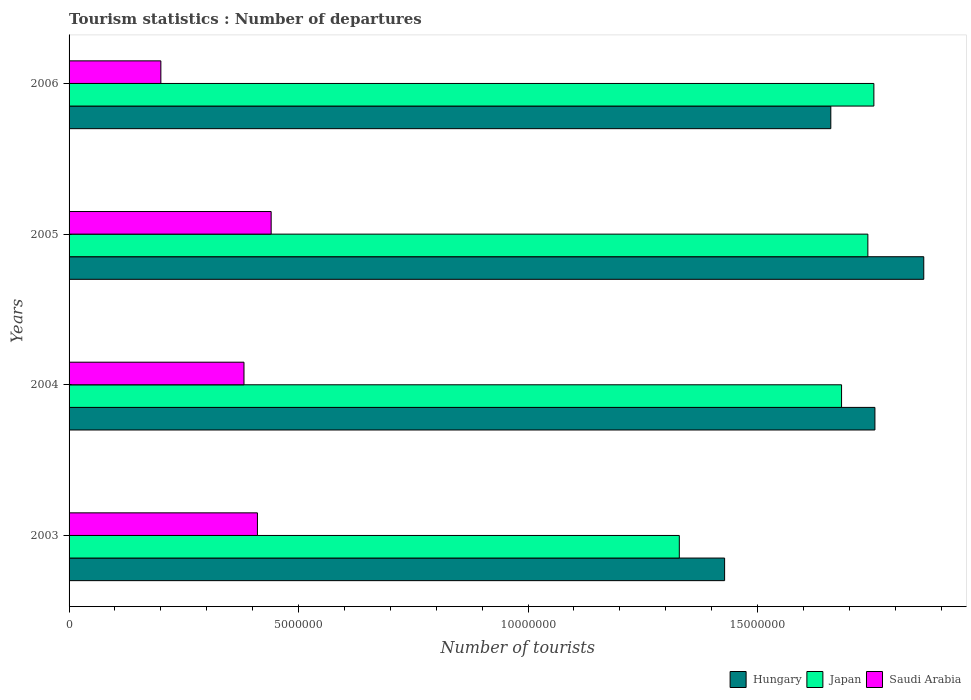How many different coloured bars are there?
Offer a very short reply. 3. How many groups of bars are there?
Give a very brief answer. 4. How many bars are there on the 3rd tick from the bottom?
Give a very brief answer. 3. What is the label of the 1st group of bars from the top?
Provide a short and direct response. 2006. What is the number of tourist departures in Japan in 2005?
Provide a short and direct response. 1.74e+07. Across all years, what is the maximum number of tourist departures in Saudi Arabia?
Ensure brevity in your answer.  4.40e+06. Across all years, what is the minimum number of tourist departures in Japan?
Your response must be concise. 1.33e+07. In which year was the number of tourist departures in Japan maximum?
Give a very brief answer. 2006. In which year was the number of tourist departures in Japan minimum?
Provide a short and direct response. 2003. What is the total number of tourist departures in Saudi Arabia in the graph?
Your answer should be compact. 1.43e+07. What is the difference between the number of tourist departures in Japan in 2005 and that in 2006?
Ensure brevity in your answer.  -1.31e+05. What is the difference between the number of tourist departures in Hungary in 2004 and the number of tourist departures in Saudi Arabia in 2005?
Provide a short and direct response. 1.32e+07. What is the average number of tourist departures in Hungary per year?
Your response must be concise. 1.68e+07. In the year 2003, what is the difference between the number of tourist departures in Hungary and number of tourist departures in Japan?
Keep it short and to the point. 9.87e+05. In how many years, is the number of tourist departures in Saudi Arabia greater than 6000000 ?
Your answer should be very brief. 0. What is the ratio of the number of tourist departures in Hungary in 2004 to that in 2006?
Provide a succinct answer. 1.06. What is the difference between the highest and the second highest number of tourist departures in Saudi Arabia?
Your response must be concise. 2.99e+05. What is the difference between the highest and the lowest number of tourist departures in Japan?
Your answer should be very brief. 4.24e+06. In how many years, is the number of tourist departures in Hungary greater than the average number of tourist departures in Hungary taken over all years?
Provide a short and direct response. 2. What does the 1st bar from the top in 2006 represents?
Keep it short and to the point. Saudi Arabia. What does the 1st bar from the bottom in 2003 represents?
Your answer should be very brief. Hungary. What is the difference between two consecutive major ticks on the X-axis?
Your answer should be very brief. 5.00e+06. Are the values on the major ticks of X-axis written in scientific E-notation?
Your answer should be very brief. No. Does the graph contain any zero values?
Ensure brevity in your answer.  No. Does the graph contain grids?
Make the answer very short. No. How many legend labels are there?
Make the answer very short. 3. What is the title of the graph?
Your response must be concise. Tourism statistics : Number of departures. What is the label or title of the X-axis?
Your answer should be very brief. Number of tourists. What is the label or title of the Y-axis?
Your answer should be compact. Years. What is the Number of tourists in Hungary in 2003?
Ensure brevity in your answer.  1.43e+07. What is the Number of tourists in Japan in 2003?
Ensure brevity in your answer.  1.33e+07. What is the Number of tourists of Saudi Arabia in 2003?
Give a very brief answer. 4.10e+06. What is the Number of tourists in Hungary in 2004?
Make the answer very short. 1.76e+07. What is the Number of tourists of Japan in 2004?
Your answer should be very brief. 1.68e+07. What is the Number of tourists of Saudi Arabia in 2004?
Your answer should be compact. 3.81e+06. What is the Number of tourists of Hungary in 2005?
Provide a succinct answer. 1.86e+07. What is the Number of tourists in Japan in 2005?
Offer a terse response. 1.74e+07. What is the Number of tourists in Saudi Arabia in 2005?
Provide a short and direct response. 4.40e+06. What is the Number of tourists of Hungary in 2006?
Your answer should be compact. 1.66e+07. What is the Number of tourists in Japan in 2006?
Ensure brevity in your answer.  1.75e+07. What is the Number of tourists of Saudi Arabia in 2006?
Your response must be concise. 2.00e+06. Across all years, what is the maximum Number of tourists of Hungary?
Your answer should be compact. 1.86e+07. Across all years, what is the maximum Number of tourists of Japan?
Keep it short and to the point. 1.75e+07. Across all years, what is the maximum Number of tourists of Saudi Arabia?
Provide a succinct answer. 4.40e+06. Across all years, what is the minimum Number of tourists in Hungary?
Ensure brevity in your answer.  1.43e+07. Across all years, what is the minimum Number of tourists of Japan?
Ensure brevity in your answer.  1.33e+07. Across all years, what is the minimum Number of tourists in Saudi Arabia?
Your answer should be very brief. 2.00e+06. What is the total Number of tourists in Hungary in the graph?
Keep it short and to the point. 6.71e+07. What is the total Number of tourists in Japan in the graph?
Provide a succinct answer. 6.51e+07. What is the total Number of tourists in Saudi Arabia in the graph?
Provide a succinct answer. 1.43e+07. What is the difference between the Number of tourists in Hungary in 2003 and that in 2004?
Your answer should be compact. -3.28e+06. What is the difference between the Number of tourists in Japan in 2003 and that in 2004?
Offer a terse response. -3.54e+06. What is the difference between the Number of tourists in Saudi Arabia in 2003 and that in 2004?
Give a very brief answer. 2.93e+05. What is the difference between the Number of tourists in Hungary in 2003 and that in 2005?
Ensure brevity in your answer.  -4.34e+06. What is the difference between the Number of tourists of Japan in 2003 and that in 2005?
Make the answer very short. -4.11e+06. What is the difference between the Number of tourists of Saudi Arabia in 2003 and that in 2005?
Provide a short and direct response. -2.99e+05. What is the difference between the Number of tourists of Hungary in 2003 and that in 2006?
Offer a terse response. -2.31e+06. What is the difference between the Number of tourists of Japan in 2003 and that in 2006?
Offer a very short reply. -4.24e+06. What is the difference between the Number of tourists of Saudi Arabia in 2003 and that in 2006?
Make the answer very short. 2.10e+06. What is the difference between the Number of tourists in Hungary in 2004 and that in 2005?
Ensure brevity in your answer.  -1.06e+06. What is the difference between the Number of tourists of Japan in 2004 and that in 2005?
Provide a short and direct response. -5.73e+05. What is the difference between the Number of tourists of Saudi Arabia in 2004 and that in 2005?
Offer a very short reply. -5.92e+05. What is the difference between the Number of tourists of Hungary in 2004 and that in 2006?
Your response must be concise. 9.61e+05. What is the difference between the Number of tourists of Japan in 2004 and that in 2006?
Give a very brief answer. -7.04e+05. What is the difference between the Number of tourists of Saudi Arabia in 2004 and that in 2006?
Ensure brevity in your answer.  1.81e+06. What is the difference between the Number of tourists in Hungary in 2005 and that in 2006?
Provide a succinct answer. 2.02e+06. What is the difference between the Number of tourists in Japan in 2005 and that in 2006?
Give a very brief answer. -1.31e+05. What is the difference between the Number of tourists in Saudi Arabia in 2005 and that in 2006?
Give a very brief answer. 2.40e+06. What is the difference between the Number of tourists in Hungary in 2003 and the Number of tourists in Japan in 2004?
Offer a very short reply. -2.55e+06. What is the difference between the Number of tourists in Hungary in 2003 and the Number of tourists in Saudi Arabia in 2004?
Your answer should be compact. 1.05e+07. What is the difference between the Number of tourists of Japan in 2003 and the Number of tourists of Saudi Arabia in 2004?
Provide a succinct answer. 9.48e+06. What is the difference between the Number of tourists of Hungary in 2003 and the Number of tourists of Japan in 2005?
Your answer should be compact. -3.12e+06. What is the difference between the Number of tourists in Hungary in 2003 and the Number of tourists in Saudi Arabia in 2005?
Provide a succinct answer. 9.88e+06. What is the difference between the Number of tourists in Japan in 2003 and the Number of tourists in Saudi Arabia in 2005?
Make the answer very short. 8.89e+06. What is the difference between the Number of tourists in Hungary in 2003 and the Number of tourists in Japan in 2006?
Your response must be concise. -3.25e+06. What is the difference between the Number of tourists in Hungary in 2003 and the Number of tourists in Saudi Arabia in 2006?
Your answer should be compact. 1.23e+07. What is the difference between the Number of tourists of Japan in 2003 and the Number of tourists of Saudi Arabia in 2006?
Offer a very short reply. 1.13e+07. What is the difference between the Number of tourists of Hungary in 2004 and the Number of tourists of Japan in 2005?
Offer a terse response. 1.54e+05. What is the difference between the Number of tourists in Hungary in 2004 and the Number of tourists in Saudi Arabia in 2005?
Your answer should be compact. 1.32e+07. What is the difference between the Number of tourists in Japan in 2004 and the Number of tourists in Saudi Arabia in 2005?
Give a very brief answer. 1.24e+07. What is the difference between the Number of tourists in Hungary in 2004 and the Number of tourists in Japan in 2006?
Offer a terse response. 2.30e+04. What is the difference between the Number of tourists of Hungary in 2004 and the Number of tourists of Saudi Arabia in 2006?
Your answer should be compact. 1.56e+07. What is the difference between the Number of tourists of Japan in 2004 and the Number of tourists of Saudi Arabia in 2006?
Offer a terse response. 1.48e+07. What is the difference between the Number of tourists of Hungary in 2005 and the Number of tourists of Japan in 2006?
Make the answer very short. 1.09e+06. What is the difference between the Number of tourists of Hungary in 2005 and the Number of tourists of Saudi Arabia in 2006?
Offer a very short reply. 1.66e+07. What is the difference between the Number of tourists of Japan in 2005 and the Number of tourists of Saudi Arabia in 2006?
Offer a very short reply. 1.54e+07. What is the average Number of tourists of Hungary per year?
Offer a very short reply. 1.68e+07. What is the average Number of tourists in Japan per year?
Your answer should be very brief. 1.63e+07. What is the average Number of tourists in Saudi Arabia per year?
Offer a terse response. 3.58e+06. In the year 2003, what is the difference between the Number of tourists of Hungary and Number of tourists of Japan?
Ensure brevity in your answer.  9.87e+05. In the year 2003, what is the difference between the Number of tourists of Hungary and Number of tourists of Saudi Arabia?
Provide a succinct answer. 1.02e+07. In the year 2003, what is the difference between the Number of tourists of Japan and Number of tourists of Saudi Arabia?
Keep it short and to the point. 9.19e+06. In the year 2004, what is the difference between the Number of tourists in Hungary and Number of tourists in Japan?
Offer a terse response. 7.27e+05. In the year 2004, what is the difference between the Number of tourists in Hungary and Number of tourists in Saudi Arabia?
Your answer should be compact. 1.37e+07. In the year 2004, what is the difference between the Number of tourists in Japan and Number of tourists in Saudi Arabia?
Your answer should be compact. 1.30e+07. In the year 2005, what is the difference between the Number of tourists of Hungary and Number of tourists of Japan?
Provide a short and direct response. 1.22e+06. In the year 2005, what is the difference between the Number of tourists in Hungary and Number of tourists in Saudi Arabia?
Give a very brief answer. 1.42e+07. In the year 2005, what is the difference between the Number of tourists of Japan and Number of tourists of Saudi Arabia?
Provide a short and direct response. 1.30e+07. In the year 2006, what is the difference between the Number of tourists of Hungary and Number of tourists of Japan?
Your answer should be compact. -9.38e+05. In the year 2006, what is the difference between the Number of tourists of Hungary and Number of tourists of Saudi Arabia?
Provide a short and direct response. 1.46e+07. In the year 2006, what is the difference between the Number of tourists of Japan and Number of tourists of Saudi Arabia?
Keep it short and to the point. 1.55e+07. What is the ratio of the Number of tourists in Hungary in 2003 to that in 2004?
Offer a very short reply. 0.81. What is the ratio of the Number of tourists in Japan in 2003 to that in 2004?
Provide a succinct answer. 0.79. What is the ratio of the Number of tourists of Saudi Arabia in 2003 to that in 2004?
Your answer should be very brief. 1.08. What is the ratio of the Number of tourists in Hungary in 2003 to that in 2005?
Ensure brevity in your answer.  0.77. What is the ratio of the Number of tourists in Japan in 2003 to that in 2005?
Make the answer very short. 0.76. What is the ratio of the Number of tourists in Saudi Arabia in 2003 to that in 2005?
Provide a short and direct response. 0.93. What is the ratio of the Number of tourists of Hungary in 2003 to that in 2006?
Your answer should be compact. 0.86. What is the ratio of the Number of tourists of Japan in 2003 to that in 2006?
Keep it short and to the point. 0.76. What is the ratio of the Number of tourists of Saudi Arabia in 2003 to that in 2006?
Ensure brevity in your answer.  2.05. What is the ratio of the Number of tourists of Hungary in 2004 to that in 2005?
Offer a very short reply. 0.94. What is the ratio of the Number of tourists of Japan in 2004 to that in 2005?
Keep it short and to the point. 0.97. What is the ratio of the Number of tourists of Saudi Arabia in 2004 to that in 2005?
Your response must be concise. 0.87. What is the ratio of the Number of tourists in Hungary in 2004 to that in 2006?
Keep it short and to the point. 1.06. What is the ratio of the Number of tourists of Japan in 2004 to that in 2006?
Provide a short and direct response. 0.96. What is the ratio of the Number of tourists in Saudi Arabia in 2004 to that in 2006?
Offer a terse response. 1.91. What is the ratio of the Number of tourists of Hungary in 2005 to that in 2006?
Provide a short and direct response. 1.12. What is the ratio of the Number of tourists of Saudi Arabia in 2005 to that in 2006?
Your response must be concise. 2.2. What is the difference between the highest and the second highest Number of tourists of Hungary?
Your answer should be compact. 1.06e+06. What is the difference between the highest and the second highest Number of tourists in Japan?
Keep it short and to the point. 1.31e+05. What is the difference between the highest and the second highest Number of tourists of Saudi Arabia?
Offer a very short reply. 2.99e+05. What is the difference between the highest and the lowest Number of tourists in Hungary?
Ensure brevity in your answer.  4.34e+06. What is the difference between the highest and the lowest Number of tourists in Japan?
Ensure brevity in your answer.  4.24e+06. What is the difference between the highest and the lowest Number of tourists of Saudi Arabia?
Make the answer very short. 2.40e+06. 